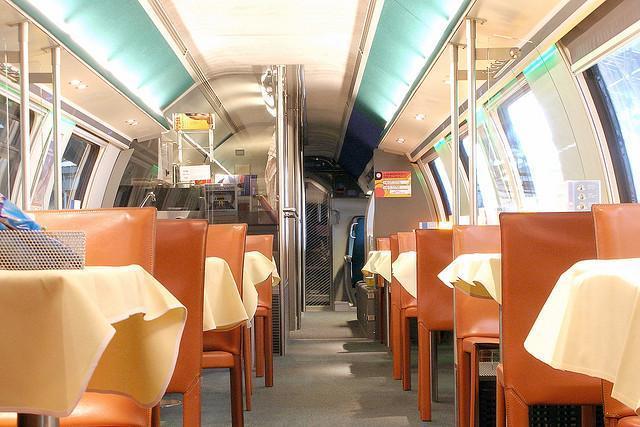How many chairs are there?
Give a very brief answer. 8. How many dining tables are visible?
Give a very brief answer. 3. 